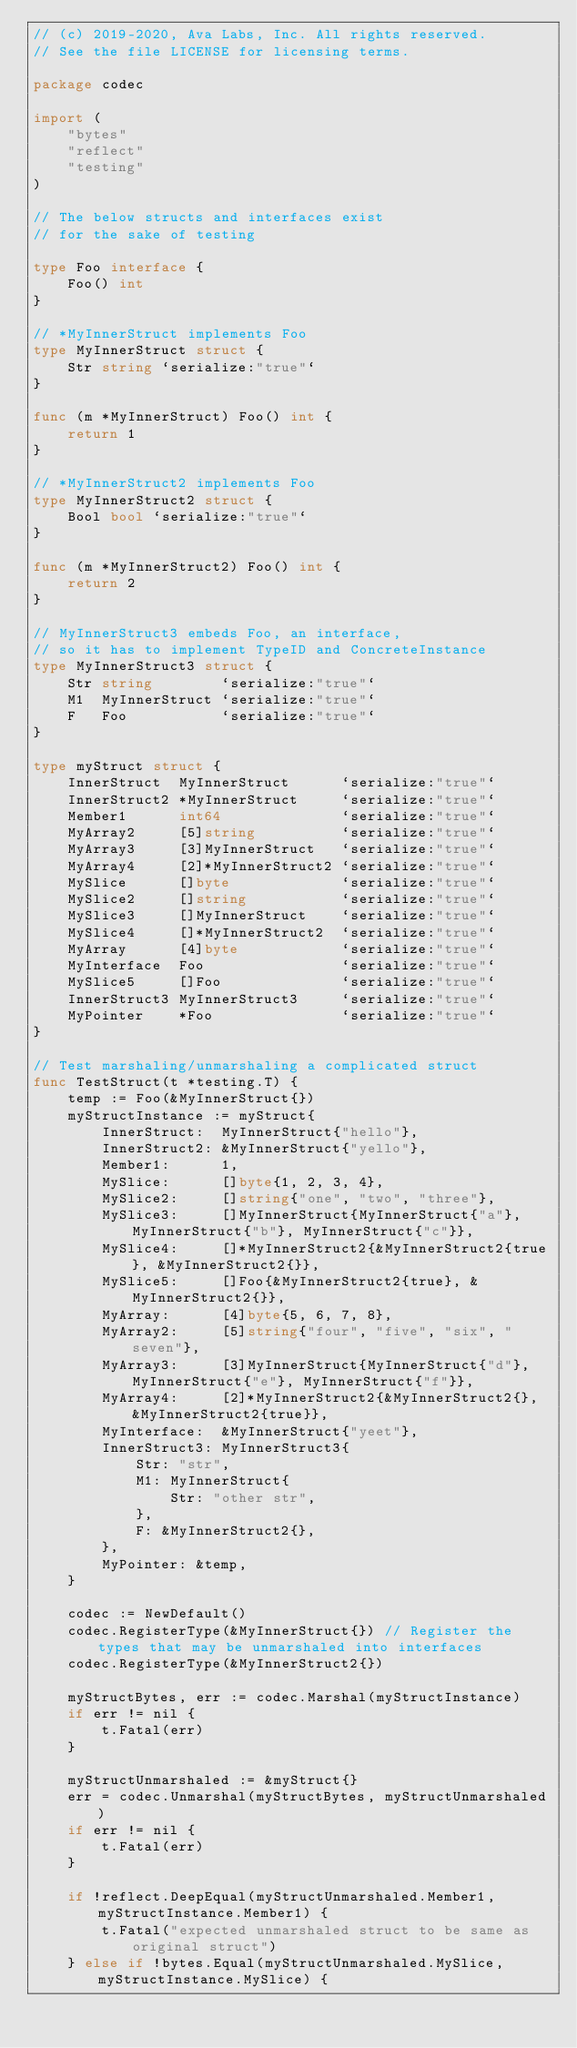<code> <loc_0><loc_0><loc_500><loc_500><_Go_>// (c) 2019-2020, Ava Labs, Inc. All rights reserved.
// See the file LICENSE for licensing terms.

package codec

import (
	"bytes"
	"reflect"
	"testing"
)

// The below structs and interfaces exist
// for the sake of testing

type Foo interface {
	Foo() int
}

// *MyInnerStruct implements Foo
type MyInnerStruct struct {
	Str string `serialize:"true"`
}

func (m *MyInnerStruct) Foo() int {
	return 1
}

// *MyInnerStruct2 implements Foo
type MyInnerStruct2 struct {
	Bool bool `serialize:"true"`
}

func (m *MyInnerStruct2) Foo() int {
	return 2
}

// MyInnerStruct3 embeds Foo, an interface,
// so it has to implement TypeID and ConcreteInstance
type MyInnerStruct3 struct {
	Str string        `serialize:"true"`
	M1  MyInnerStruct `serialize:"true"`
	F   Foo           `serialize:"true"`
}

type myStruct struct {
	InnerStruct  MyInnerStruct      `serialize:"true"`
	InnerStruct2 *MyInnerStruct     `serialize:"true"`
	Member1      int64              `serialize:"true"`
	MyArray2     [5]string          `serialize:"true"`
	MyArray3     [3]MyInnerStruct   `serialize:"true"`
	MyArray4     [2]*MyInnerStruct2 `serialize:"true"`
	MySlice      []byte             `serialize:"true"`
	MySlice2     []string           `serialize:"true"`
	MySlice3     []MyInnerStruct    `serialize:"true"`
	MySlice4     []*MyInnerStruct2  `serialize:"true"`
	MyArray      [4]byte            `serialize:"true"`
	MyInterface  Foo                `serialize:"true"`
	MySlice5     []Foo              `serialize:"true"`
	InnerStruct3 MyInnerStruct3     `serialize:"true"`
	MyPointer    *Foo               `serialize:"true"`
}

// Test marshaling/unmarshaling a complicated struct
func TestStruct(t *testing.T) {
	temp := Foo(&MyInnerStruct{})
	myStructInstance := myStruct{
		InnerStruct:  MyInnerStruct{"hello"},
		InnerStruct2: &MyInnerStruct{"yello"},
		Member1:      1,
		MySlice:      []byte{1, 2, 3, 4},
		MySlice2:     []string{"one", "two", "three"},
		MySlice3:     []MyInnerStruct{MyInnerStruct{"a"}, MyInnerStruct{"b"}, MyInnerStruct{"c"}},
		MySlice4:     []*MyInnerStruct2{&MyInnerStruct2{true}, &MyInnerStruct2{}},
		MySlice5:     []Foo{&MyInnerStruct2{true}, &MyInnerStruct2{}},
		MyArray:      [4]byte{5, 6, 7, 8},
		MyArray2:     [5]string{"four", "five", "six", "seven"},
		MyArray3:     [3]MyInnerStruct{MyInnerStruct{"d"}, MyInnerStruct{"e"}, MyInnerStruct{"f"}},
		MyArray4:     [2]*MyInnerStruct2{&MyInnerStruct2{}, &MyInnerStruct2{true}},
		MyInterface:  &MyInnerStruct{"yeet"},
		InnerStruct3: MyInnerStruct3{
			Str: "str",
			M1: MyInnerStruct{
				Str: "other str",
			},
			F: &MyInnerStruct2{},
		},
		MyPointer: &temp,
	}

	codec := NewDefault()
	codec.RegisterType(&MyInnerStruct{}) // Register the types that may be unmarshaled into interfaces
	codec.RegisterType(&MyInnerStruct2{})

	myStructBytes, err := codec.Marshal(myStructInstance)
	if err != nil {
		t.Fatal(err)
	}

	myStructUnmarshaled := &myStruct{}
	err = codec.Unmarshal(myStructBytes, myStructUnmarshaled)
	if err != nil {
		t.Fatal(err)
	}

	if !reflect.DeepEqual(myStructUnmarshaled.Member1, myStructInstance.Member1) {
		t.Fatal("expected unmarshaled struct to be same as original struct")
	} else if !bytes.Equal(myStructUnmarshaled.MySlice, myStructInstance.MySlice) {</code> 